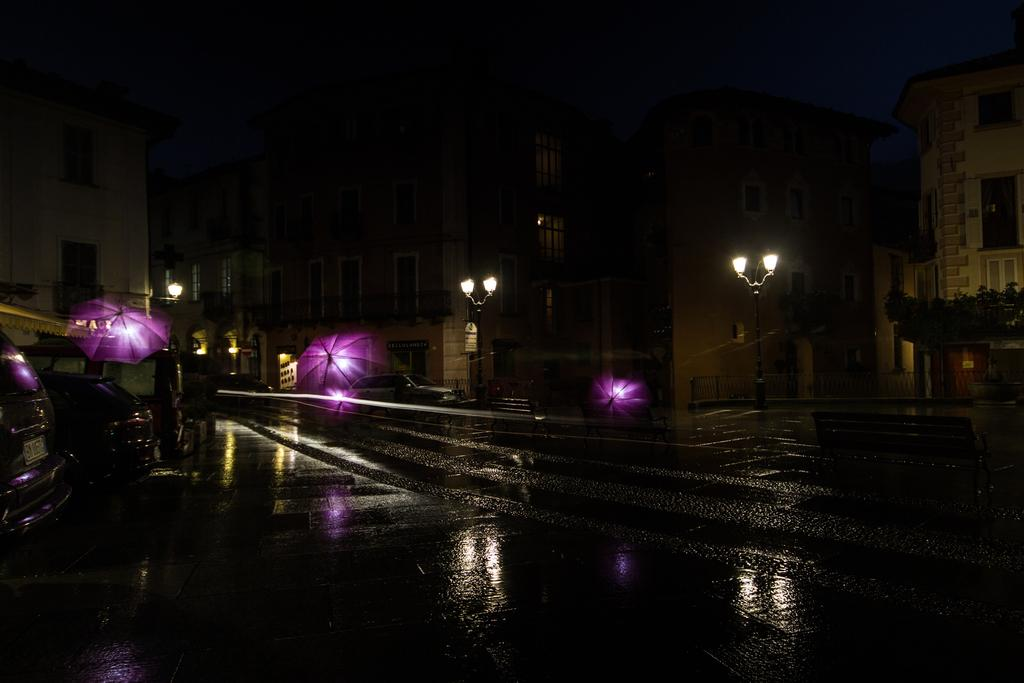What type of structures can be seen in the image? There are buildings in the image. What is illuminating the area in front of the buildings? Street lights are present in front of the buildings. What can be found on the ground near the buildings? Vehicles are parked on the ground. What is the surface that connects the buildings and vehicles? There is a road visible in the image. What type of natural elements are present in the image? Plants are present in the image. What type of addition problem can be solved using the license plate numbers of the parked vehicles? There is no mention of license plate numbers or addition problems in the image, so this question cannot be answered definitively. 